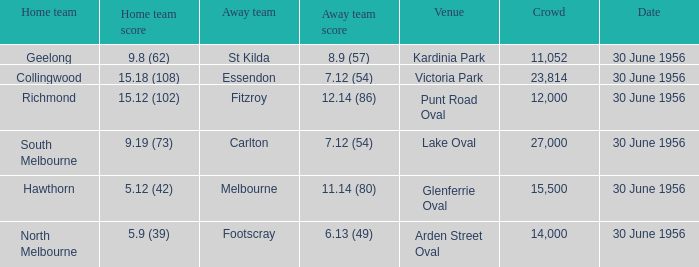What is the home team at Victoria Park with an Away team score of 7.12 (54) and more than 12,000 people? Collingwood. 